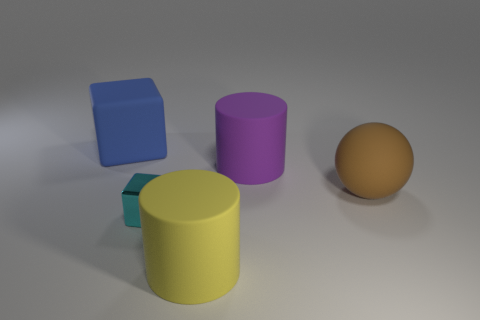Subtract all gray blocks. Subtract all yellow spheres. How many blocks are left? 2 Add 4 blue things. How many objects exist? 9 Subtract all cylinders. How many objects are left? 3 Add 5 big things. How many big things exist? 9 Subtract 0 yellow spheres. How many objects are left? 5 Subtract all cyan rubber cylinders. Subtract all brown balls. How many objects are left? 4 Add 5 blue blocks. How many blue blocks are left? 6 